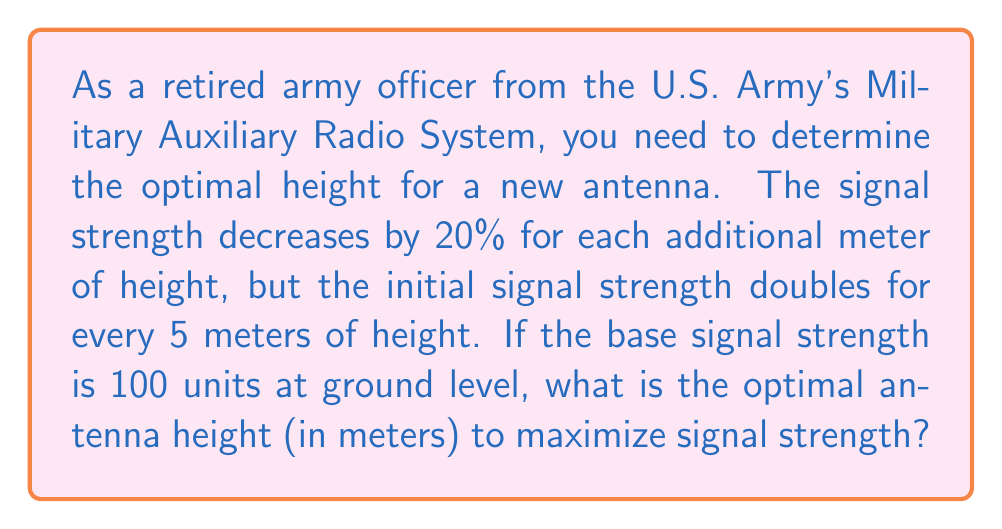Could you help me with this problem? Let's approach this step-by-step:

1) First, let's define our variables:
   $h$ = height in meters
   $S(h)$ = signal strength at height $h$

2) We can express the signal strength as a product of two factors:
   $S(h) = 100 \cdot 2^{\lfloor h/5 \rfloor} \cdot (0.8)^h$

   Where:
   - 100 is the base signal strength
   - $2^{\lfloor h/5 \rfloor}$ accounts for doubling every 5 meters
   - $(0.8)^h$ accounts for the 20% decrease per meter (0.8 = 1 - 0.2)

3) To find the maximum, we need to find the height where $S(h+1) \leq S(h)$:

   $100 \cdot 2^{\lfloor (h+1)/5 \rfloor} \cdot (0.8)^{h+1} \leq 100 \cdot 2^{\lfloor h/5 \rfloor} \cdot (0.8)^h$

4) This inequality is always true when $h$ is not a multiple of 5. At multiples of 5, we have:

   $2^{(h+1)/5} \cdot (0.8)^{h+1} \leq 2^{h/5} \cdot (0.8)^h$

5) Simplifying:

   $2 \cdot 0.8 \leq 1$

   $1.6 \leq 1$

6) This inequality becomes true when $h = 15$, as:

   $S(15) = 100 \cdot 2^3 \cdot (0.8)^{15} \approx 167.77$
   $S(16) = 100 \cdot 2^3 \cdot (0.8)^{16} \approx 134.22$

Therefore, the signal strength reaches its maximum at 15 meters.
Answer: 15 meters 